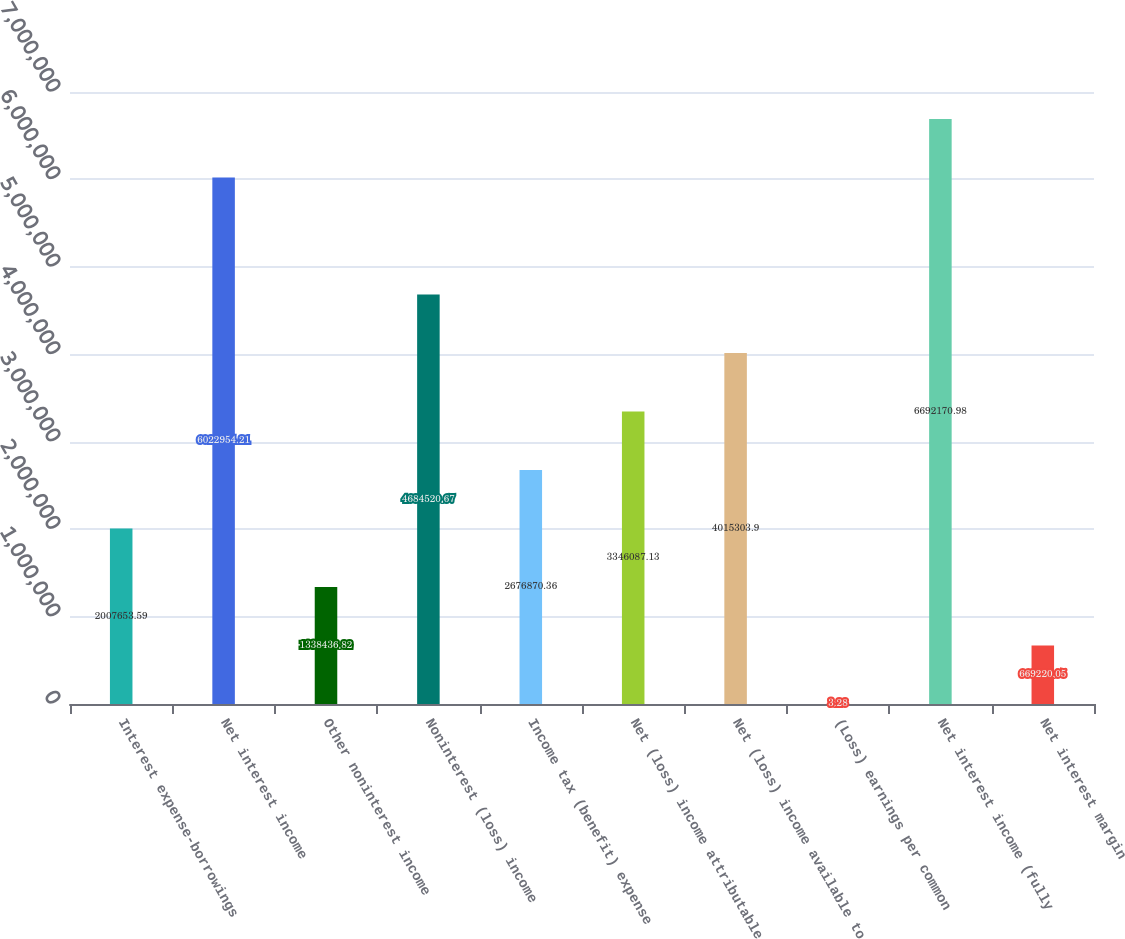<chart> <loc_0><loc_0><loc_500><loc_500><bar_chart><fcel>Interest expense-borrowings<fcel>Net interest income<fcel>Other noninterest income<fcel>Noninterest (loss) income<fcel>Income tax (benefit) expense<fcel>Net (loss) income attributable<fcel>Net (loss) income available to<fcel>(Loss) earnings per common<fcel>Net interest income (fully<fcel>Net interest margin<nl><fcel>2.00765e+06<fcel>6.02295e+06<fcel>1.33844e+06<fcel>4.68452e+06<fcel>2.67687e+06<fcel>3.34609e+06<fcel>4.0153e+06<fcel>3.28<fcel>6.69217e+06<fcel>669220<nl></chart> 